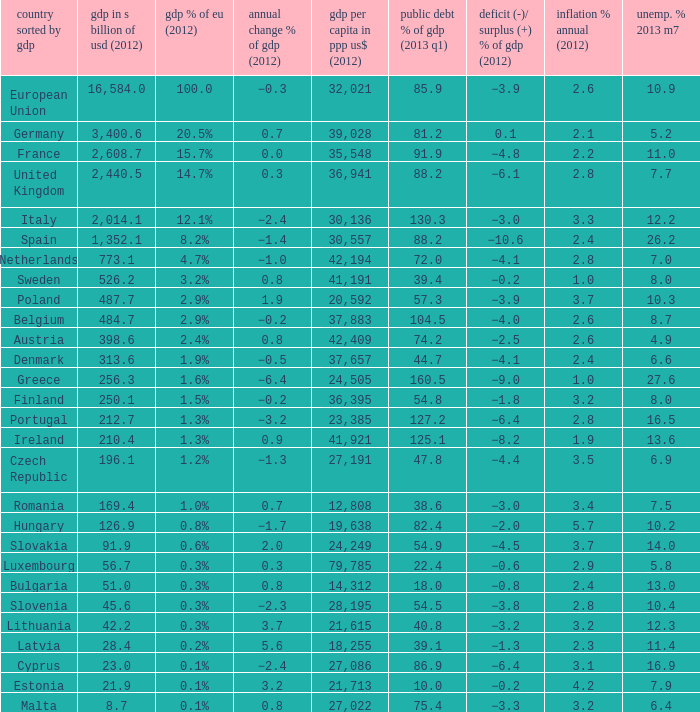What is the deficit/surplus % of the 2012 GDP of the country with a GDP in billions of USD in 2012 less than 1,352.1, a GDP per capita in PPP US dollars in 2012 greater than 21,615, public debt % of GDP in the 2013 Q1 less than 75.4, and an inflation % annual in 2012 of 2.9? −0.6. 